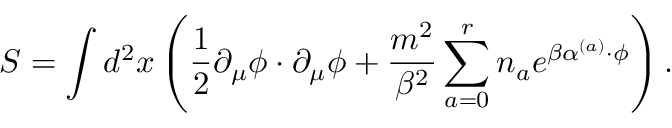<formula> <loc_0><loc_0><loc_500><loc_500>S = \int d ^ { 2 } x \left ( \frac { 1 } { 2 } \partial _ { \mu } \phi \cdot \partial _ { \mu } \phi + \frac { m ^ { 2 } } { \beta ^ { 2 } } \sum _ { a = 0 } ^ { r } n _ { a } e ^ { \beta \alpha ^ { ( a ) } \cdot \phi } \right ) .</formula> 